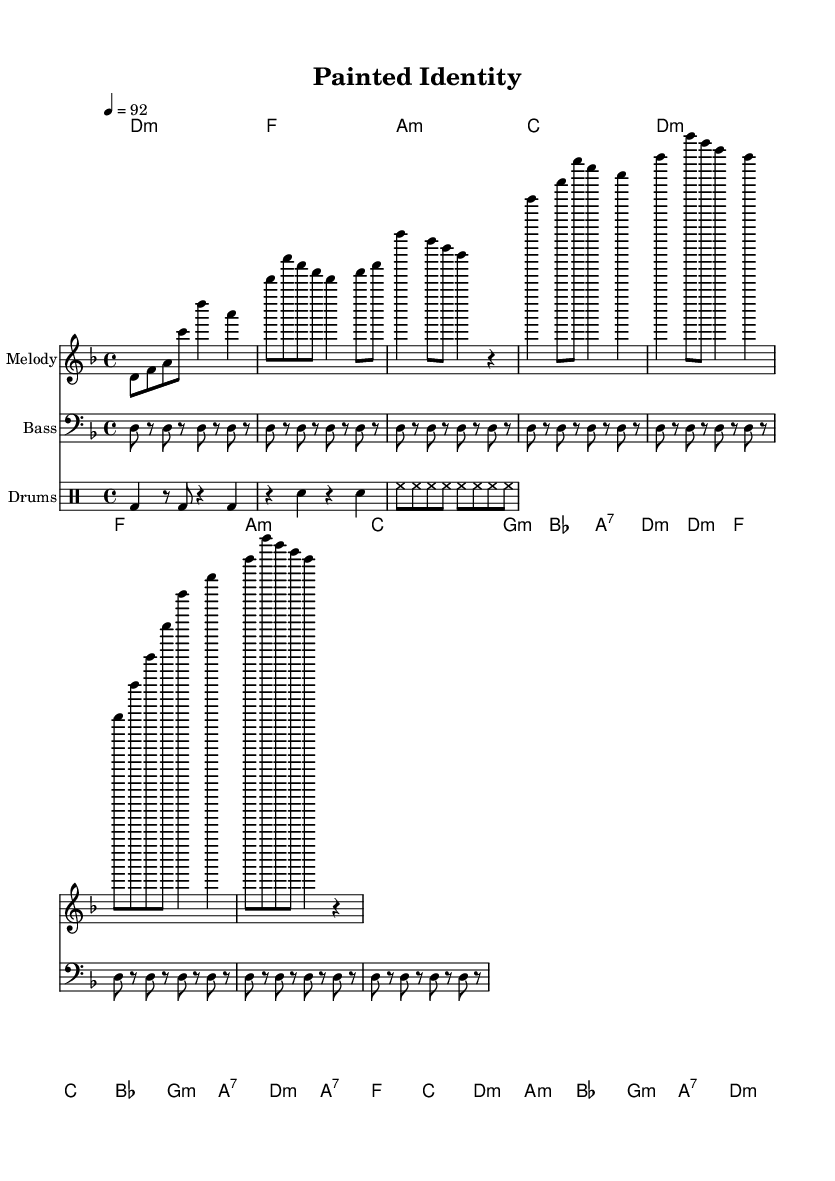What is the key signature of this music? The key signature is indicated at the beginning of the sheet music, where it shows one flat (B), which corresponds to D minor.
Answer: D minor What is the time signature of this music? The time signature appears at the start of the piece, showing a 4 over 4 configuration, indicating four beats per measure.
Answer: 4/4 What is the tempo indicated in the score? The tempo marking is shown as "4 = 92," which means there are 92 quarter note beats per minute.
Answer: 92 How many sections are in the structure of this piece? By analyzing the score, the structure is broken down into four sections: Intro, Verse, Chorus, and Bridge.
Answer: Four Which chords are used in the Verse section? The verse section includes the following chords listed in order: D minor, F, A minor, C, G minor, B flat, A7, and D minor.
Answer: D minor, F, A minor, C, G minor, B flat, A7, D minor What type of instrumental texture is used in this Hip Hop piece? This piece uses a combination of melody, harmonies, bass lines, and rhythmic drum patterns, typical for Hip Hop, exploring layered textures.
Answer: Layered textures What is the purpose of the repeated drum pattern? The repeated drum pattern serves to provide a consistent rhythmic foundation that drives the piece forward, highlighting the beats essential in Hip Hop music.
Answer: Consistent rhythmic foundation 